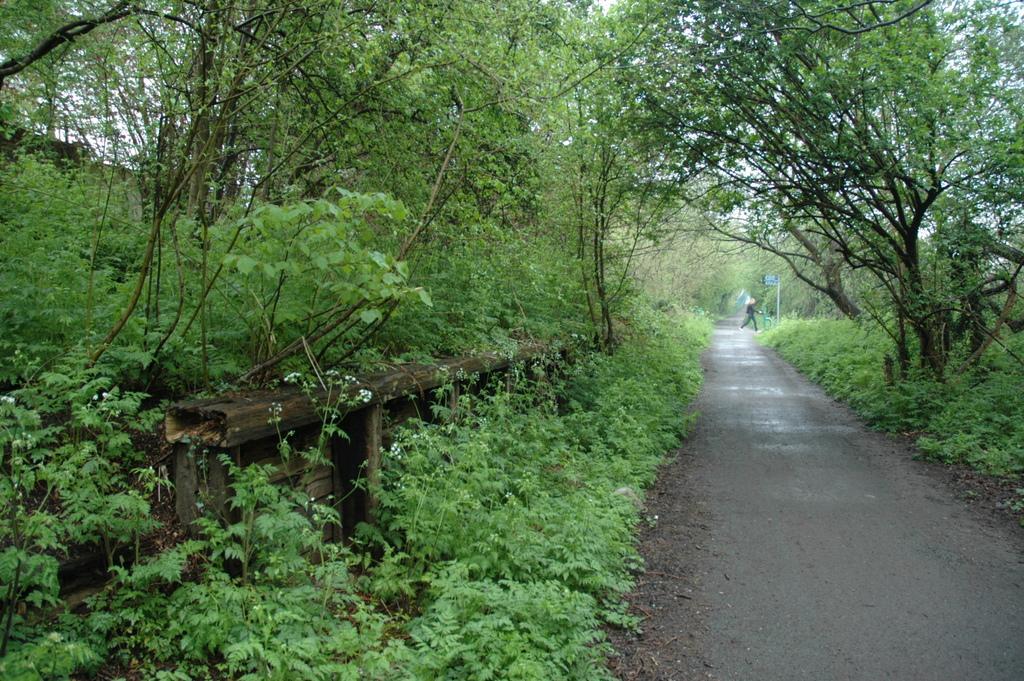How would you summarize this image in a sentence or two? In this image there are trees, plants and there is a person walking. 